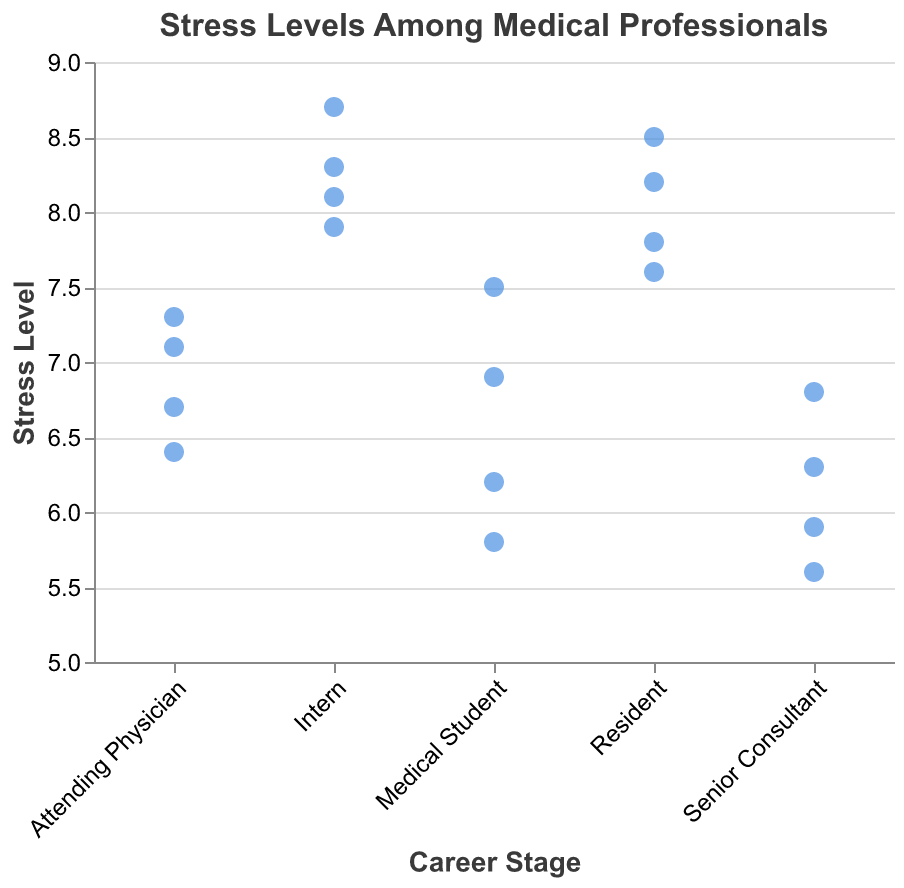What is the title of the figure? The title of the figure is usually displayed at the top and it gives a summary of what the chart is about. Here, the title is "Stress Levels Among Medical Professionals" as mentioned in the code description.
Answer: Stress Levels Among Medical Professionals Which career stage reports the highest average stress level? To determine the highest average stress level, we can look at the different career stages and their associated stress levels. Interns oftentimes report higher stress levels as shown with values between 7.9 and 8.7. We calculate that the average stress level for Interns is higher than other career stages.
Answer: Intern How many data points are shown for the 'Resident' career stage? Each point represents a data entry for 'Resident'. By counting the number of points aligned vertically under the 'Resident' career stage label, we can see there are four data points.
Answer: 4 What is the minimum stress level reported by Medical Students? By inspecting the vertical points for the 'Medical Student' category along the Y-axis, the lowest point is at 5.8.
Answer: 5.8 Which career stage has the widest range of stress levels reported? To find the widest range, we look at the difference between the highest and lowest stress levels within each category. Interns have stress levels ranging from 7.9 to 8.7, giving a range of 0.8, which is the widest among all career stages.
Answer: Intern Compare the average stress levels between 'Resident' and 'Attending Physician'. Which is higher and by how much? First, calculate the average stress level for Residents: (7.6 + 8.2 + 7.8 + 8.5) / 4 = 8.025. For Attending Physicians: (6.7 + 7.1 + 6.4 + 7.3) / 4 = 6.875. The difference in average stress levels between Residents and Attending Physicians is 8.025 - 6.875 = 1.15, with Residents being higher.
Answer: Residents by 1.15 What is the median stress level for 'Senior Consultant'? Arrange the stress levels for Senior Consultants: 5.6, 5.9, 6.3, 6.8. Since there are four values, the median is the average of the two middle values: (5.9 + 6.3) / 2 = 6.1.
Answer: 6.1 Which career stage has the least variation in reported stress levels? Variation can be approximated by visually inspecting the clustering of points. Medical Students' stress levels range from 5.8 to 7.5, Residents range from 7.6 to 8.5, Attending Physicians range from 6.4 to 7.3, and Senior Consultants range from 5.6 to 6.8. Senior Consultants have the most tightly clustered points.
Answer: Senior Consultant Is the stress level for every 'Intern' higher than the stress level for every 'Medical Student'? By inspecting the range of stress levels for Interns (7.9-8.7) and Medical Students (5.8-7.5), we see that the lowest Intern stress level (7.9) is still above the highest Medical Student stress level (7.5), making the statement true.
Answer: Yes 